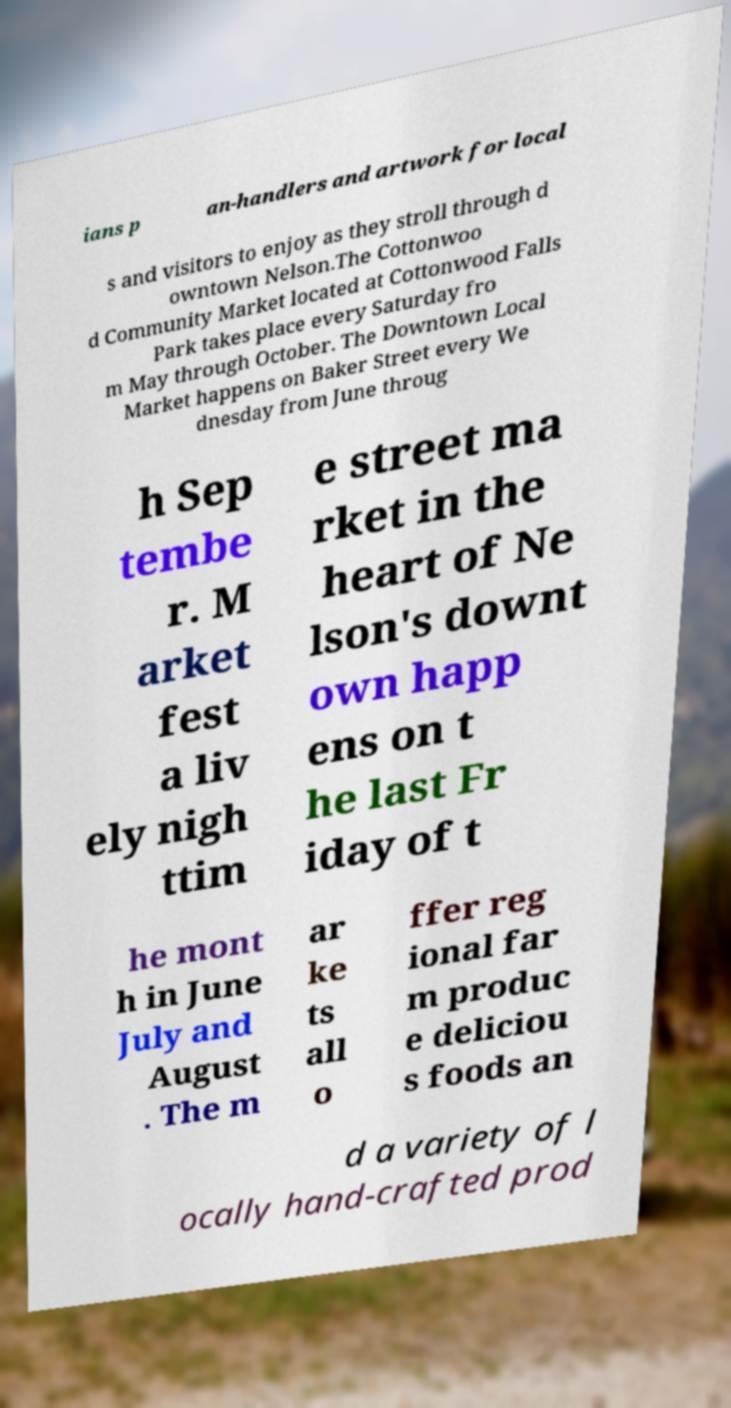There's text embedded in this image that I need extracted. Can you transcribe it verbatim? ians p an-handlers and artwork for local s and visitors to enjoy as they stroll through d owntown Nelson.The Cottonwoo d Community Market located at Cottonwood Falls Park takes place every Saturday fro m May through October. The Downtown Local Market happens on Baker Street every We dnesday from June throug h Sep tembe r. M arket fest a liv ely nigh ttim e street ma rket in the heart of Ne lson's downt own happ ens on t he last Fr iday of t he mont h in June July and August . The m ar ke ts all o ffer reg ional far m produc e deliciou s foods an d a variety of l ocally hand-crafted prod 